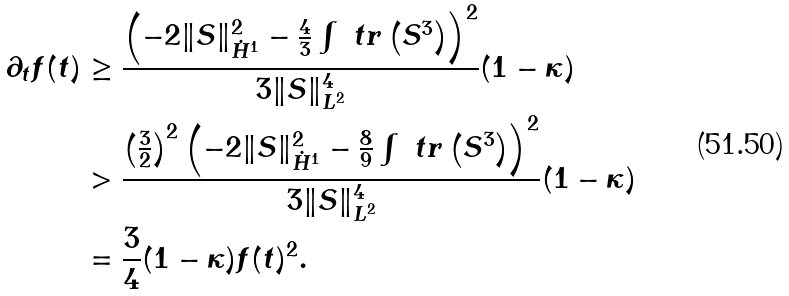Convert formula to latex. <formula><loc_0><loc_0><loc_500><loc_500>\partial _ { t } f ( t ) & \geq \frac { \left ( - 2 \| S \| _ { \dot { H } ^ { 1 } } ^ { 2 } - \frac { 4 } { 3 } \int \ t r \left ( S ^ { 3 } \right ) \right ) ^ { 2 } } { 3 \| S \| _ { L ^ { 2 } } ^ { 4 } } ( 1 - \kappa ) \\ & > \frac { \left ( \frac { 3 } { 2 } \right ) ^ { 2 } \left ( - 2 \| S \| _ { \dot { H } ^ { 1 } } ^ { 2 } - \frac { 8 } { 9 } \int \ t r \left ( S ^ { 3 } \right ) \right ) ^ { 2 } } { 3 \| S \| _ { L ^ { 2 } } ^ { 4 } } ( 1 - \kappa ) \\ & = \frac { 3 } { 4 } ( 1 - \kappa ) f ( t ) ^ { 2 } .</formula> 